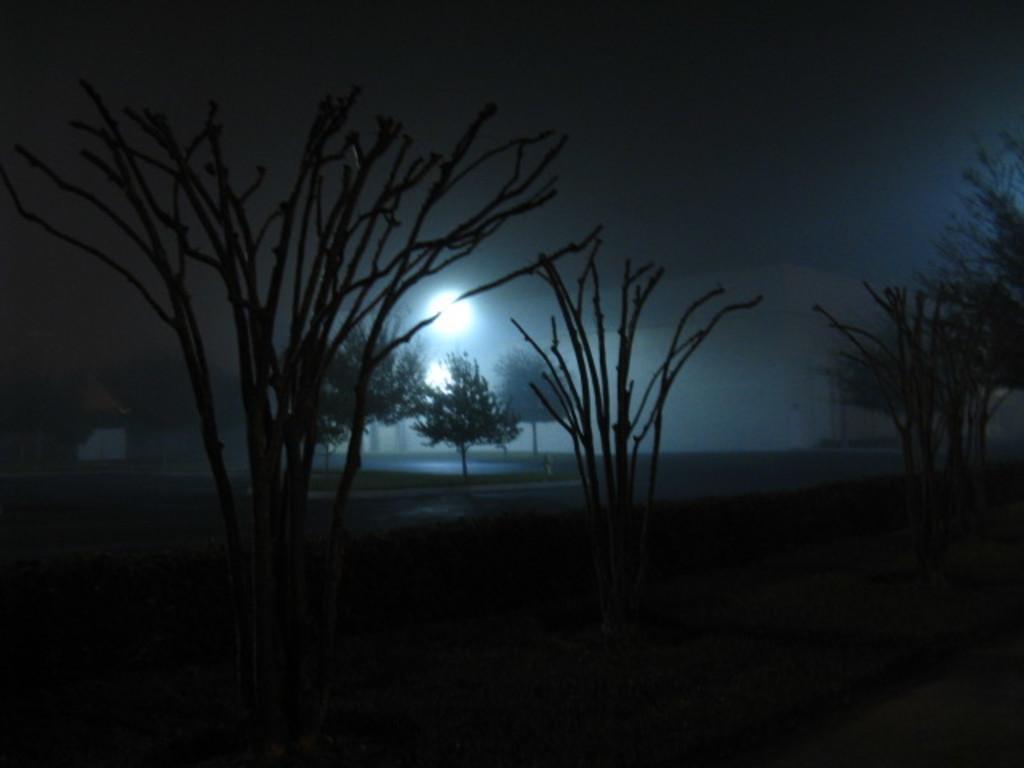Can you describe this image briefly? In this image I can see the dark picture in which I can see few trees, a building, a light and the sky. 